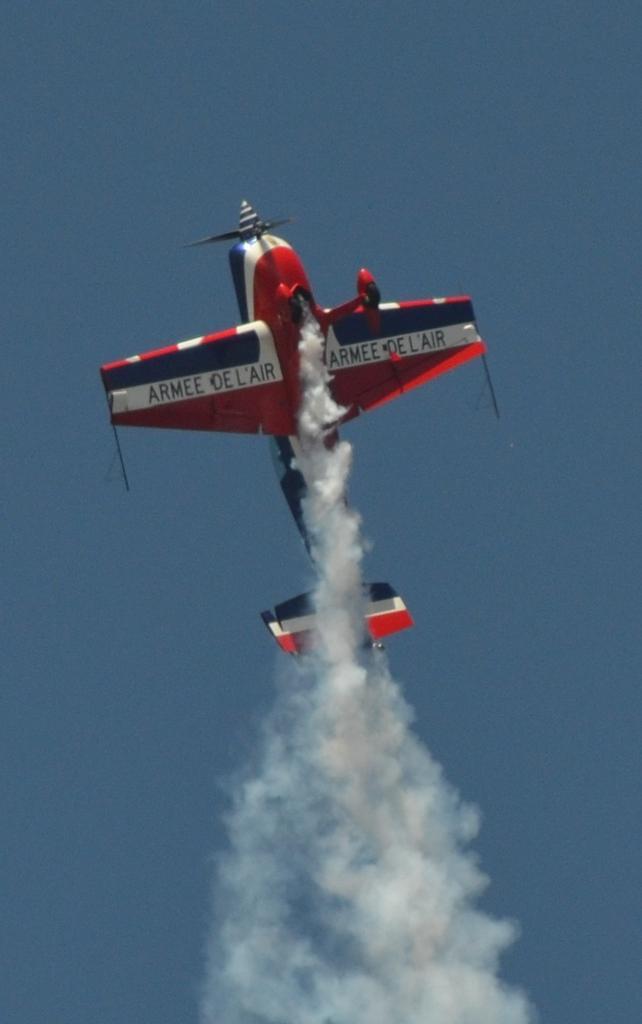Describe this image in one or two sentences. In this image we can see an aircraft flying in the air. 